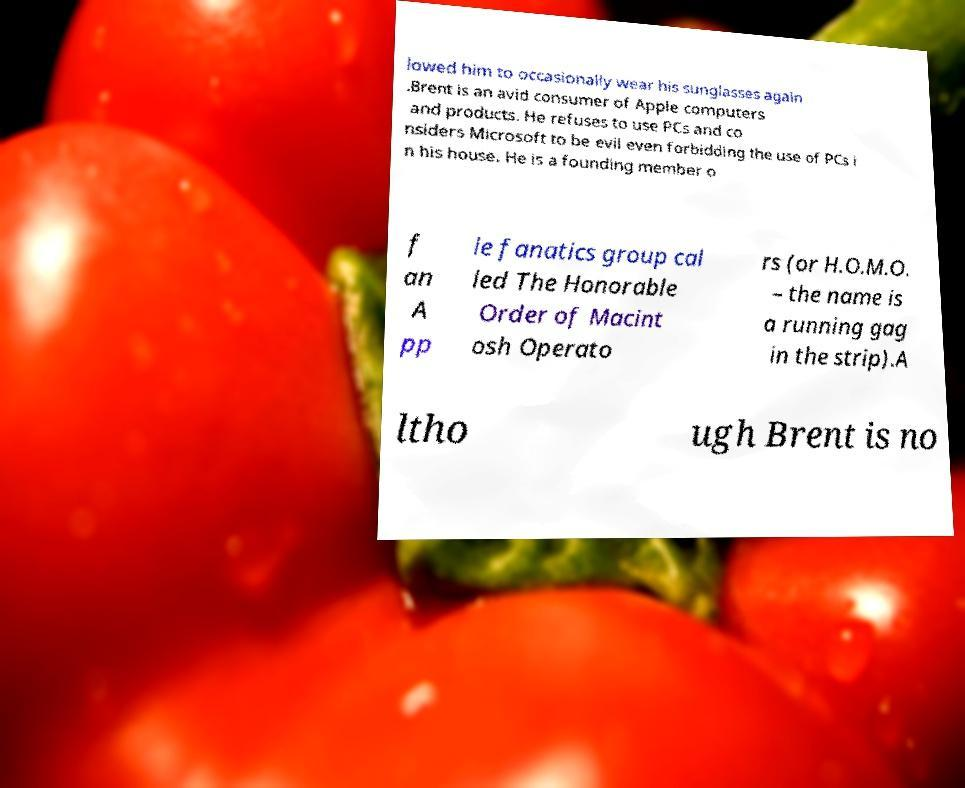Could you assist in decoding the text presented in this image and type it out clearly? lowed him to occasionally wear his sunglasses again .Brent is an avid consumer of Apple computers and products. He refuses to use PCs and co nsiders Microsoft to be evil even forbidding the use of PCs i n his house. He is a founding member o f an A pp le fanatics group cal led The Honorable Order of Macint osh Operato rs (or H.O.M.O. – the name is a running gag in the strip).A ltho ugh Brent is no 